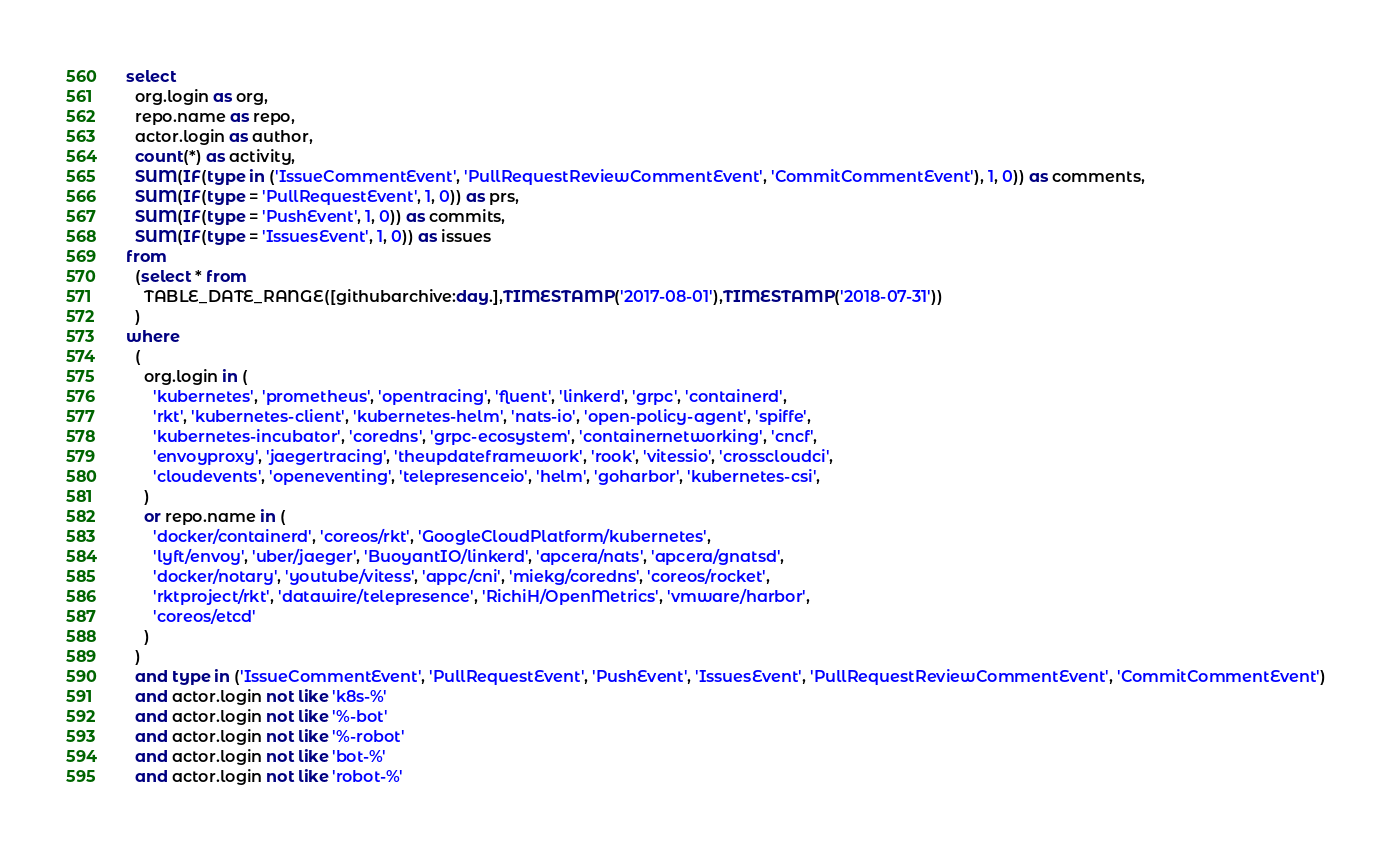<code> <loc_0><loc_0><loc_500><loc_500><_SQL_>select
  org.login as org,
  repo.name as repo,
  actor.login as author,
  count(*) as activity,
  SUM(IF(type in ('IssueCommentEvent', 'PullRequestReviewCommentEvent', 'CommitCommentEvent'), 1, 0)) as comments,
  SUM(IF(type = 'PullRequestEvent', 1, 0)) as prs,
  SUM(IF(type = 'PushEvent', 1, 0)) as commits,
  SUM(IF(type = 'IssuesEvent', 1, 0)) as issues
from
  (select * from
    TABLE_DATE_RANGE([githubarchive:day.],TIMESTAMP('2017-08-01'),TIMESTAMP('2018-07-31'))
  )
where
  (
    org.login in (
      'kubernetes', 'prometheus', 'opentracing', 'fluent', 'linkerd', 'grpc', 'containerd',
      'rkt', 'kubernetes-client', 'kubernetes-helm', 'nats-io', 'open-policy-agent', 'spiffe',
      'kubernetes-incubator', 'coredns', 'grpc-ecosystem', 'containernetworking', 'cncf',
      'envoyproxy', 'jaegertracing', 'theupdateframework', 'rook', 'vitessio', 'crosscloudci',
      'cloudevents', 'openeventing', 'telepresenceio', 'helm', 'goharbor', 'kubernetes-csi',
    )
    or repo.name in (
      'docker/containerd', 'coreos/rkt', 'GoogleCloudPlatform/kubernetes', 
      'lyft/envoy', 'uber/jaeger', 'BuoyantIO/linkerd', 'apcera/nats', 'apcera/gnatsd',
      'docker/notary', 'youtube/vitess', 'appc/cni', 'miekg/coredns', 'coreos/rocket',
      'rktproject/rkt', 'datawire/telepresence', 'RichiH/OpenMetrics', 'vmware/harbor',
      'coreos/etcd'
    )
  )
  and type in ('IssueCommentEvent', 'PullRequestEvent', 'PushEvent', 'IssuesEvent', 'PullRequestReviewCommentEvent', 'CommitCommentEvent')
  and actor.login not like 'k8s-%'
  and actor.login not like '%-bot'
  and actor.login not like '%-robot'
  and actor.login not like 'bot-%'
  and actor.login not like 'robot-%'</code> 